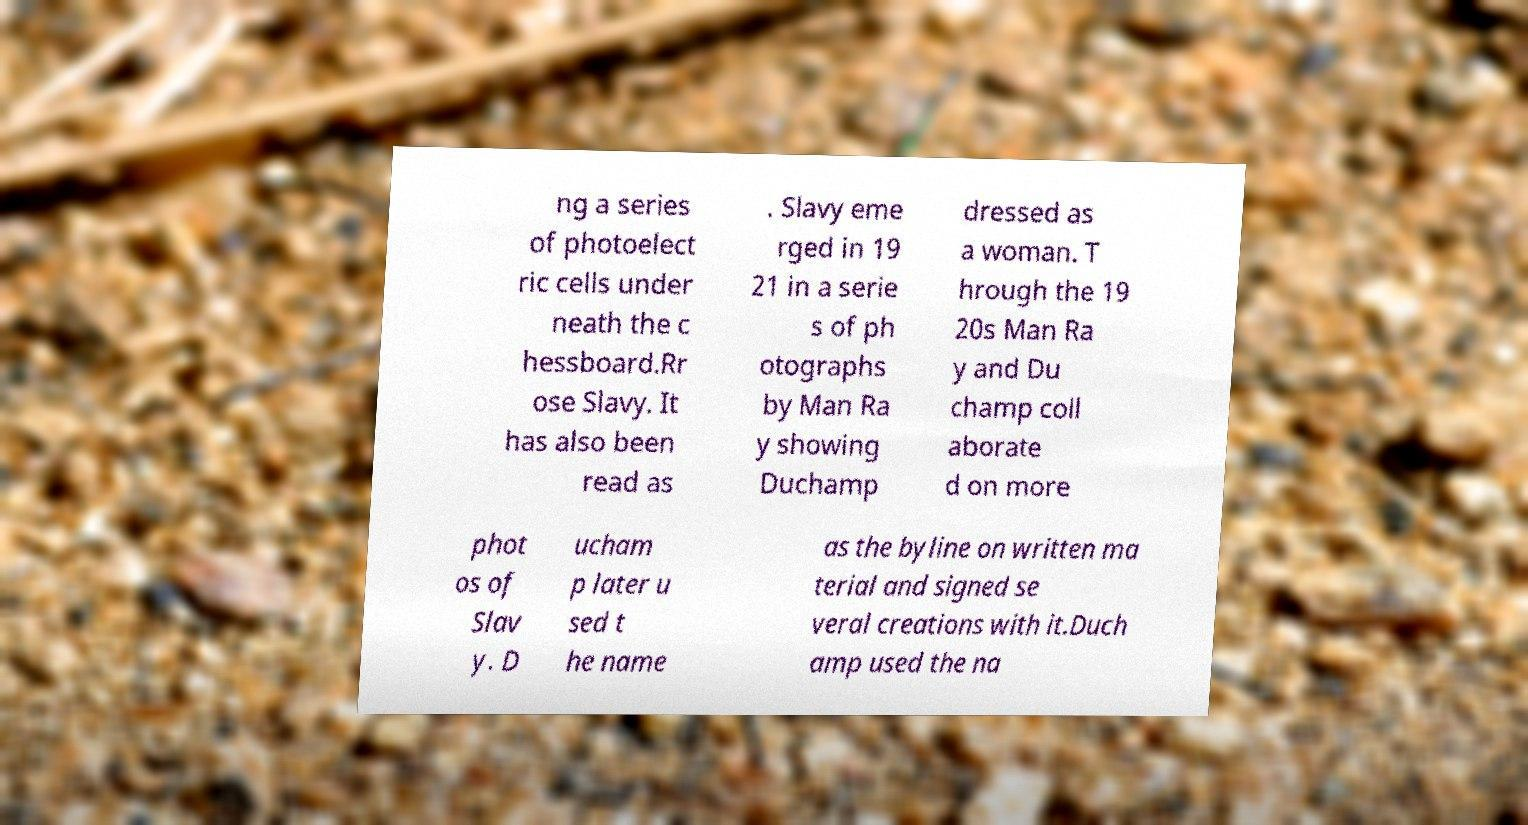What messages or text are displayed in this image? I need them in a readable, typed format. ng a series of photoelect ric cells under neath the c hessboard.Rr ose Slavy. It has also been read as . Slavy eme rged in 19 21 in a serie s of ph otographs by Man Ra y showing Duchamp dressed as a woman. T hrough the 19 20s Man Ra y and Du champ coll aborate d on more phot os of Slav y. D ucham p later u sed t he name as the byline on written ma terial and signed se veral creations with it.Duch amp used the na 